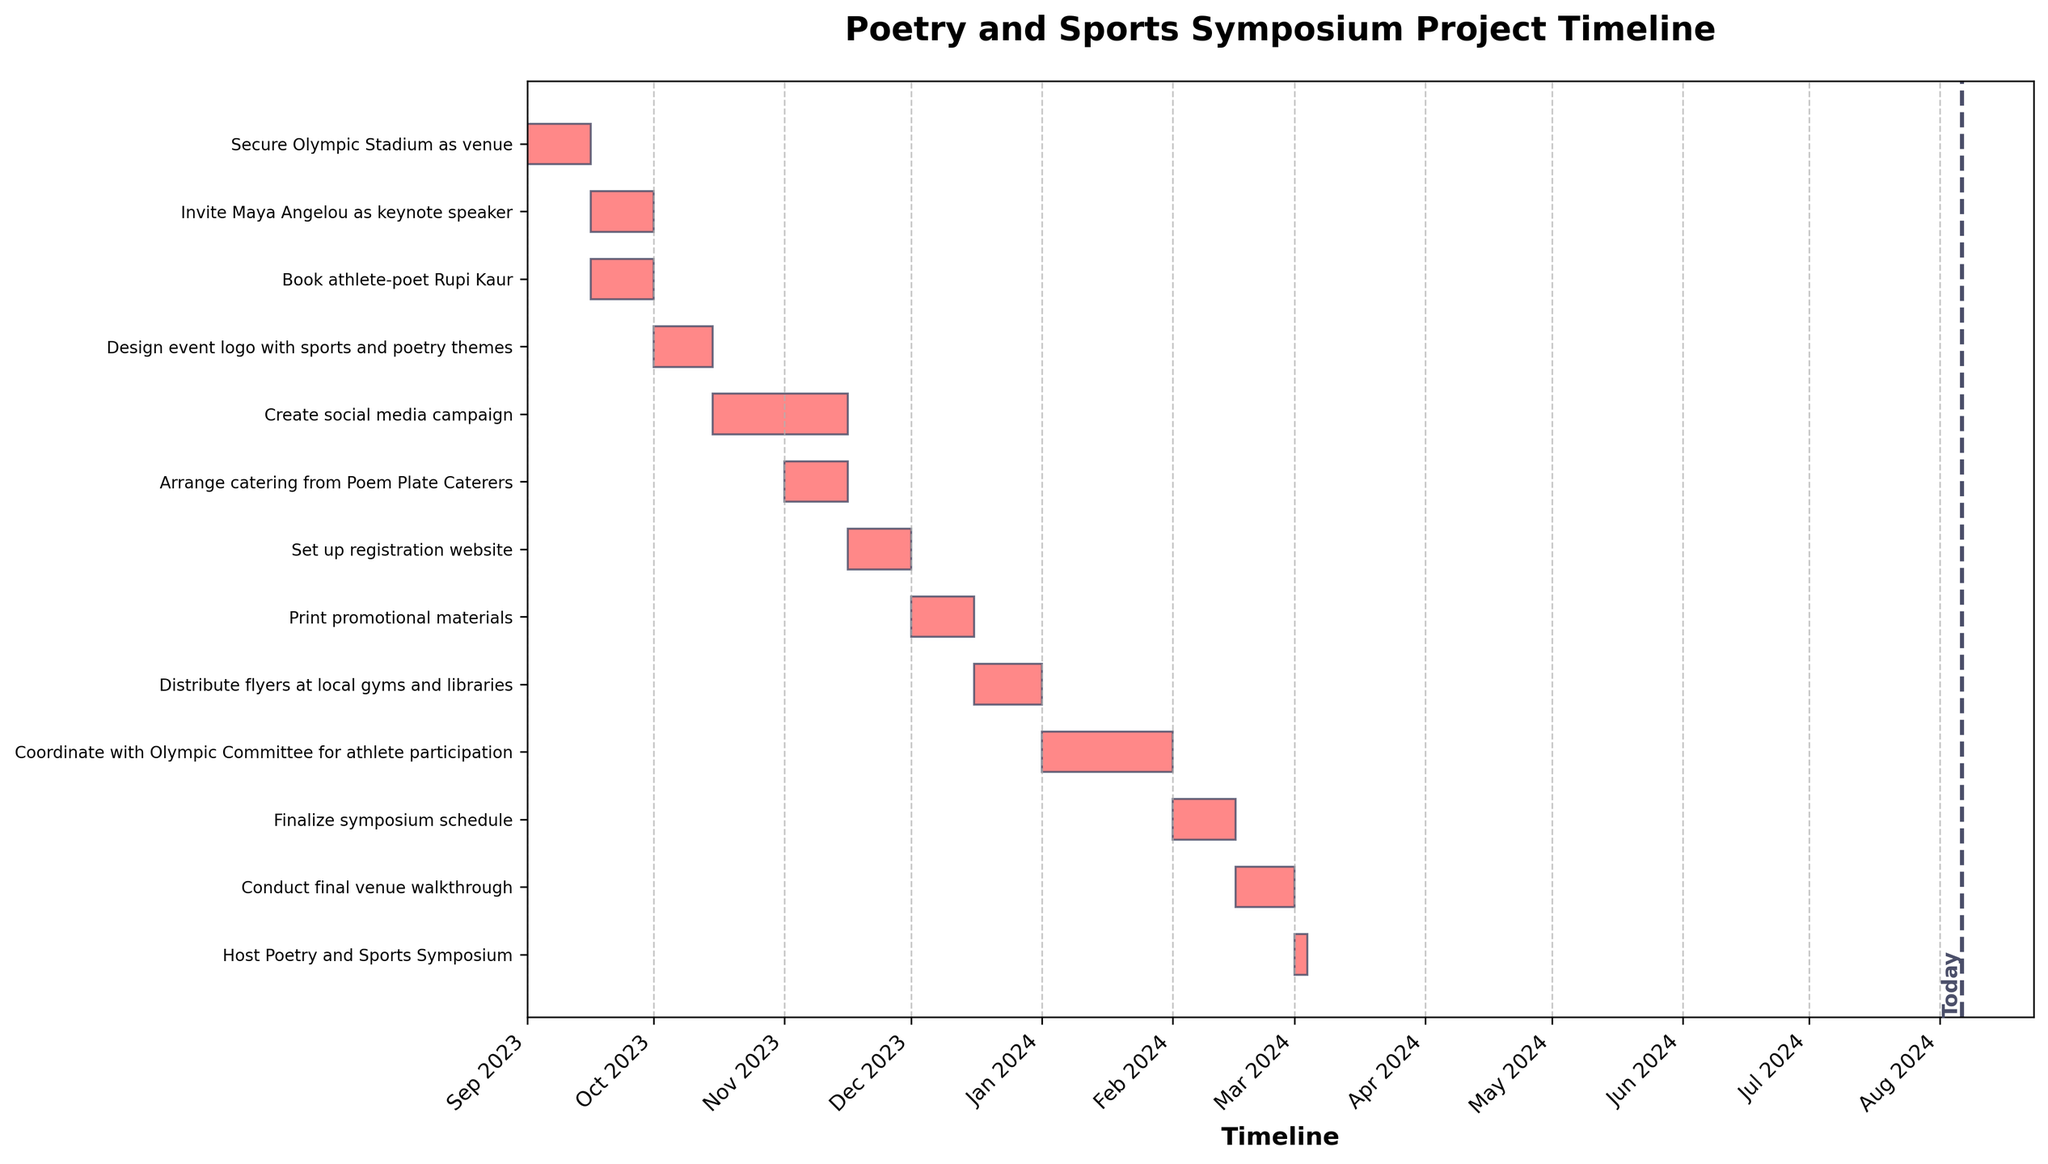Which task has the longest duration? Look at the horizontal bars in the Gantt chart and compare their lengths. The task with the longest bar (corresponding to the most extended timeline) is "Create social media campaign."
Answer: Create social media campaign What is the title of the Gantt chart? Read the text at the top of the figure where titles are commonly placed. The title is "Poetry and Sports Symposium Project Timeline."
Answer: Poetry and Sports Symposium Project Timeline During which months do the tasks "Coordinate with Olympic Committee for athlete participation" and "Finalize symposium schedule" occur? Locate the bars for these tasks and check their positions along the timeline. "Coordinate with Olympic Committee for athlete participation" is in January 2024, and "Finalize symposium schedule" is in February 2024.
Answer: January 2024 and February 2024 Which task starts immediately after the "Secure Olympic Stadium as venue"? Find the end date of "Secure Olympic Stadium as venue" and see which task's start date follows it directly. The next task is "Invite Maya Angelou as keynote speaker."
Answer: Invite Maya Angelou as keynote speaker How many tasks have a duration of exactly 15 days? In the Gantt chart, identify the tasks with bars of the same length corresponding to a 15-day duration. Count these tasks, and there are five: "Secure Olympic Stadium as venue," "Invite Maya Angelou as keynote speaker," "Book athlete-poet Rupi Kaur," "Arrange catering from Poem Plate Caterers," and "Set up registration website."
Answer: Five What is the duration of the "Host Poetry and Sports Symposium" task? Check the length of the bar for the task "Host Poetry and Sports Symposium." It is 3 days long.
Answer: 3 days Which task overlaps partially with both "Create social media campaign" and "Arrange catering from Poem Plate Caterers"? Look at the timeline to identify tasks overlapping with both "Create social media campaign" and "Arrange catering from Poem Plate Caterers." The task that fits this criterion is "Arrange catering from Poem Plate Caterers."
Answer: Arrange catering from Poem Plate Caterers Which task marks the final preparation phase before the symposium? Find the task immediately preceding the "Host Poetry and Sports Symposium." It is "Conduct final venue walkthrough."
Answer: Conduct final venue walkthrough What is the cumulative duration of all tasks in the project? Sum the durations of all the tasks listed in the Gantt chart. Add up 15 + 15 + 15 + 14 + 32 + 15 + 15 + 15 + 16 + 31 + 15 + 14 + 3 = 225 days.
Answer: 225 days Which task spans the transition from 2023 to 2024? Identify the task whose timeline covers the end of December 2023 and continues into January 2024. "Distribute flyers at local gyms and libraries" spans this transition.
Answer: Distribute flyers at local gyms and libraries 